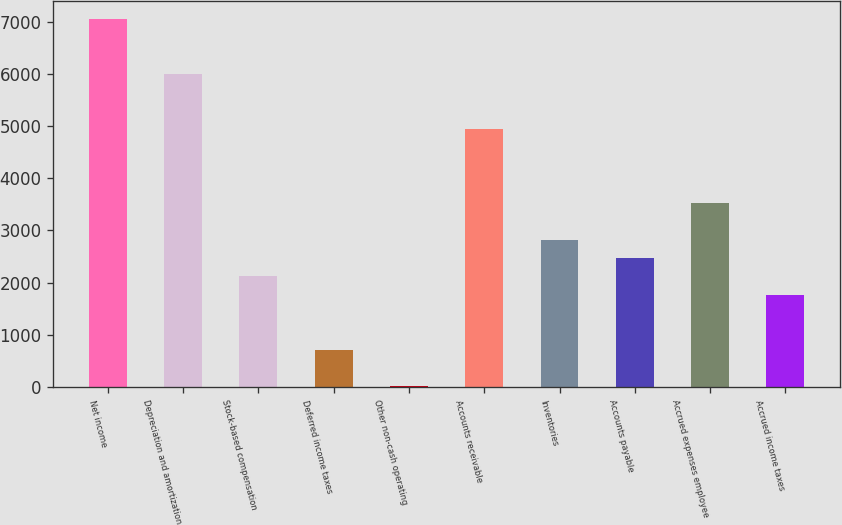Convert chart to OTSL. <chart><loc_0><loc_0><loc_500><loc_500><bar_chart><fcel>Net income<fcel>Depreciation and amortization<fcel>Stock-based compensation<fcel>Deferred income taxes<fcel>Other non-cash operating<fcel>Accounts receivable<fcel>Inventories<fcel>Accounts payable<fcel>Accrued expenses employee<fcel>Accrued income taxes<nl><fcel>7044<fcel>5989.2<fcel>2121.6<fcel>715.2<fcel>12<fcel>4934.4<fcel>2824.8<fcel>2473.2<fcel>3528<fcel>1770<nl></chart> 